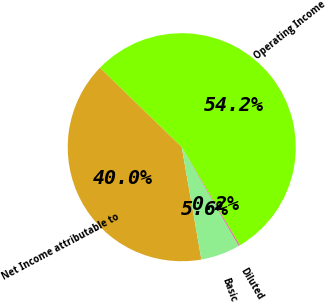Convert chart to OTSL. <chart><loc_0><loc_0><loc_500><loc_500><pie_chart><fcel>Operating Income<fcel>Net Income attributable to<fcel>Basic<fcel>Diluted<nl><fcel>54.22%<fcel>40.02%<fcel>5.58%<fcel>0.18%<nl></chart> 